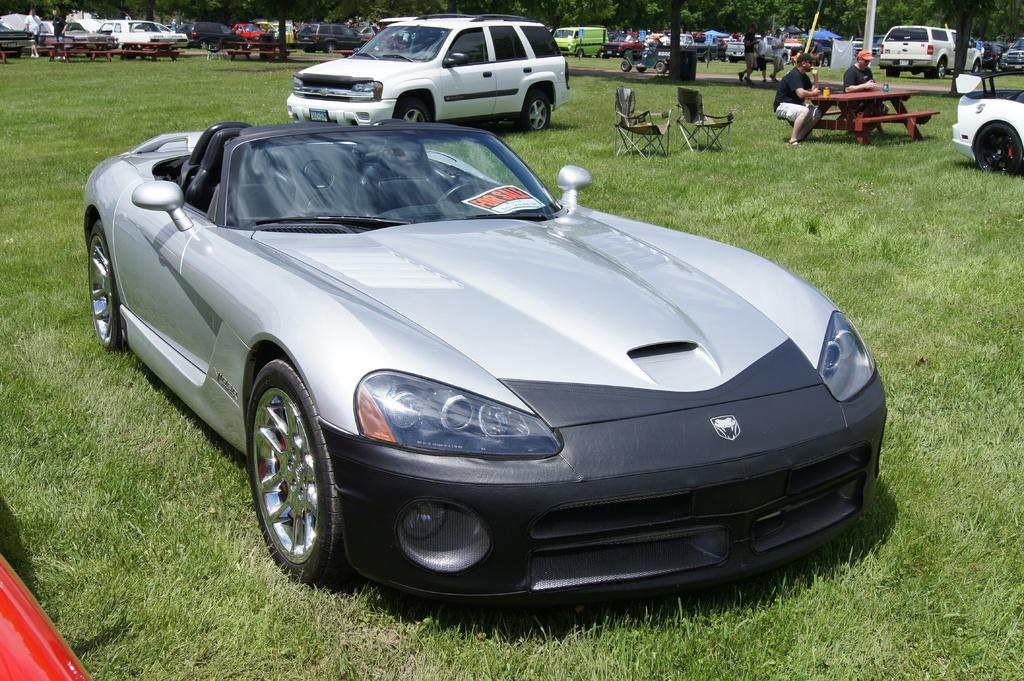What types of objects can be seen in the image? There are vehicles, chairs, tables, and a bench in the image. What is the natural environment like in the image? Grass and trees are present in the image. Are there any people in the image? Yes, people are in the image. Can you describe the seating arrangement in the image? Two persons are sitting on a bench in the image. What type of dress is the secretary wearing in the image? There is no secretary present in the image, so it is not possible to answer that question. 